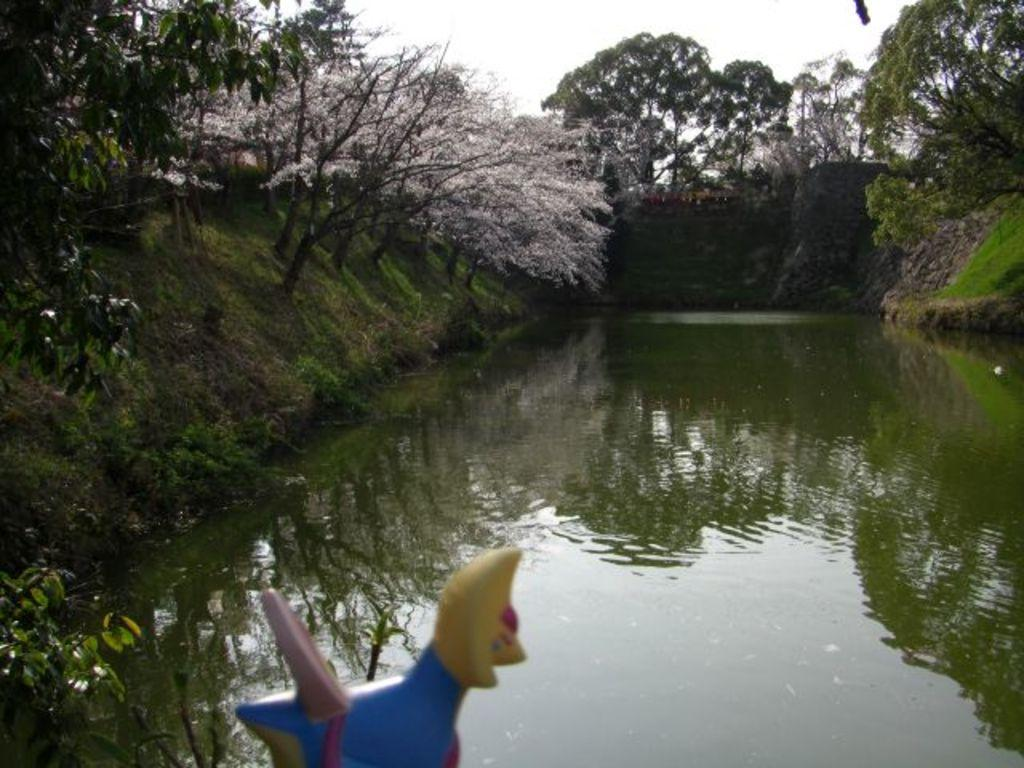What type of vegetation can be seen in the image? There are trees in the image. What else can be seen on the ground in the image? There is grass in the image. What body of water is present in the image? There is a lake in the image. What is visible above the trees and grass in the image? The sky is visible in the image. Where is the advertisement for the face cream located in the image? There is no advertisement or face cream present in the image. Can you see a tub in the lake in the image? There is no tub visible in the lake or anywhere else in the image. 